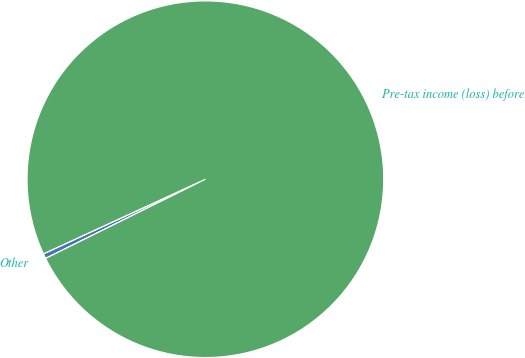Convert chart to OTSL. <chart><loc_0><loc_0><loc_500><loc_500><pie_chart><fcel>Other<fcel>Pre-tax income (loss) before<nl><fcel>0.45%<fcel>99.55%<nl></chart> 